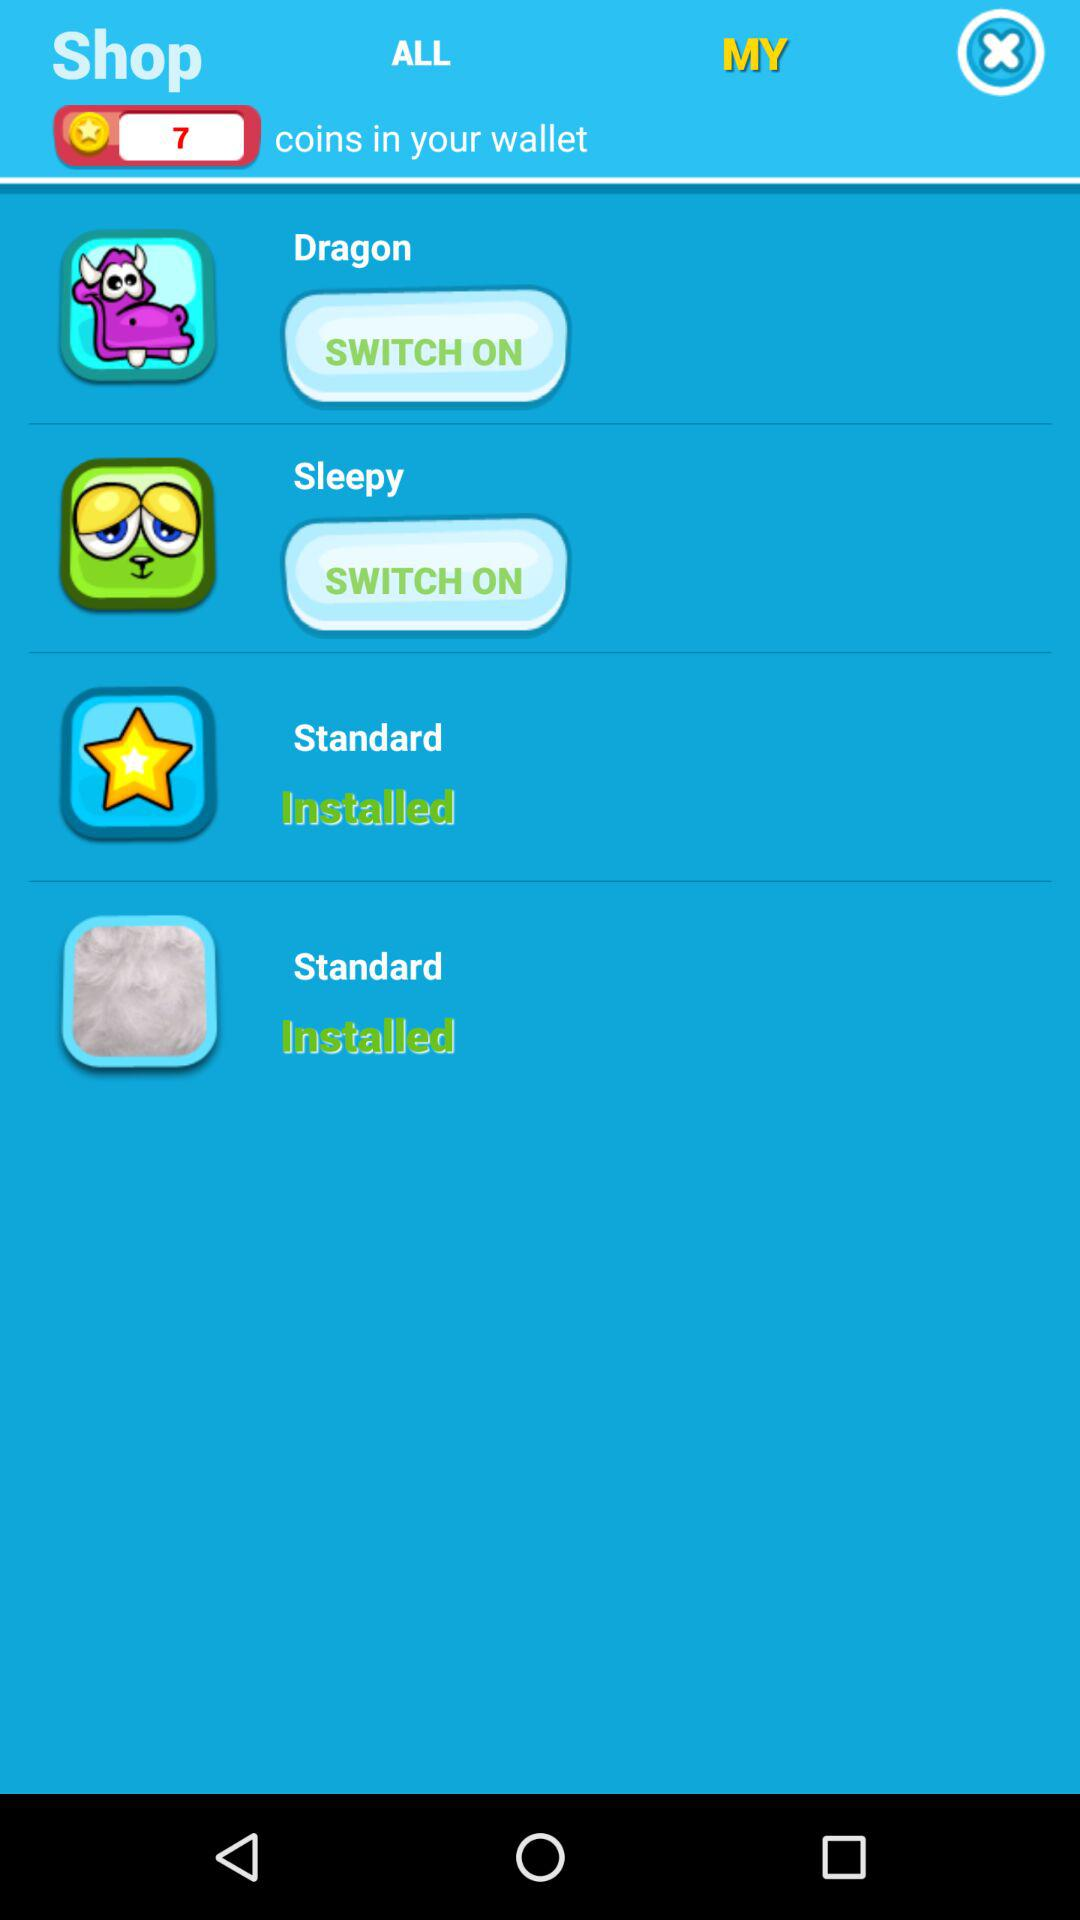How many coins are in the wallet? The number of coins in the wallet is 7. 